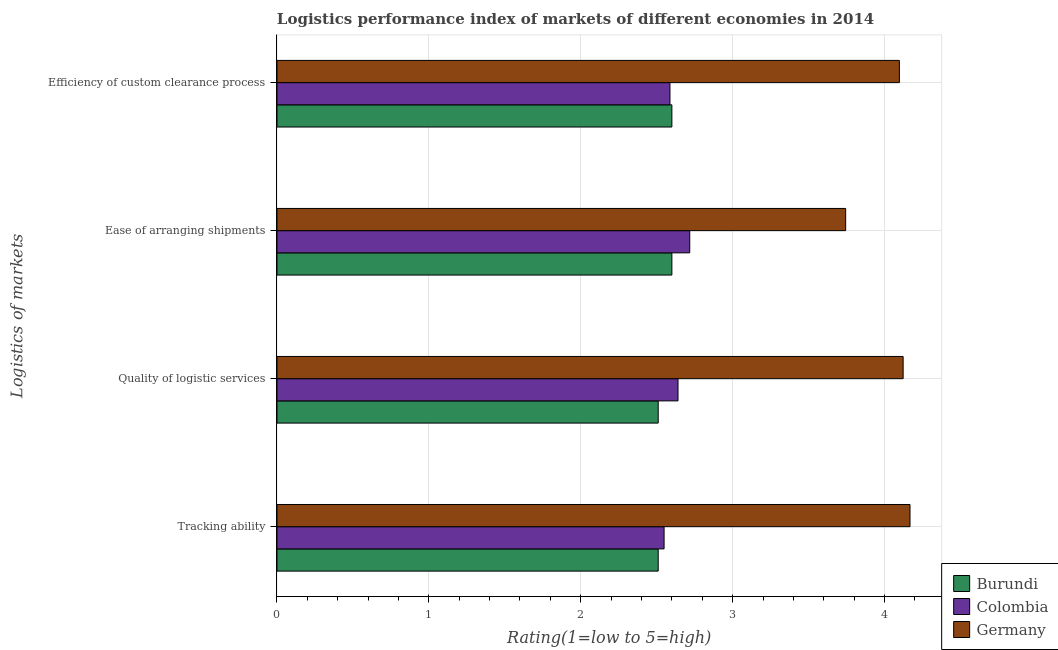How many different coloured bars are there?
Provide a short and direct response. 3. How many groups of bars are there?
Provide a short and direct response. 4. Are the number of bars per tick equal to the number of legend labels?
Your answer should be compact. Yes. What is the label of the 4th group of bars from the top?
Give a very brief answer. Tracking ability. What is the lpi rating of ease of arranging shipments in Germany?
Give a very brief answer. 3.74. Across all countries, what is the maximum lpi rating of quality of logistic services?
Offer a terse response. 4.12. Across all countries, what is the minimum lpi rating of ease of arranging shipments?
Offer a very short reply. 2.6. In which country was the lpi rating of quality of logistic services minimum?
Provide a short and direct response. Burundi. What is the total lpi rating of efficiency of custom clearance process in the graph?
Ensure brevity in your answer.  9.29. What is the difference between the lpi rating of ease of arranging shipments in Colombia and that in Germany?
Your answer should be very brief. -1.03. What is the difference between the lpi rating of quality of logistic services in Colombia and the lpi rating of efficiency of custom clearance process in Germany?
Offer a terse response. -1.46. What is the average lpi rating of efficiency of custom clearance process per country?
Provide a short and direct response. 3.1. What is the difference between the lpi rating of quality of logistic services and lpi rating of tracking ability in Colombia?
Your answer should be compact. 0.09. In how many countries, is the lpi rating of tracking ability greater than 0.6000000000000001 ?
Offer a very short reply. 3. What is the ratio of the lpi rating of tracking ability in Colombia to that in Germany?
Your answer should be compact. 0.61. Is the lpi rating of tracking ability in Germany less than that in Burundi?
Your response must be concise. No. Is the difference between the lpi rating of ease of arranging shipments in Burundi and Germany greater than the difference between the lpi rating of quality of logistic services in Burundi and Germany?
Provide a short and direct response. Yes. What is the difference between the highest and the second highest lpi rating of efficiency of custom clearance process?
Offer a very short reply. 1.5. What is the difference between the highest and the lowest lpi rating of tracking ability?
Ensure brevity in your answer.  1.66. In how many countries, is the lpi rating of ease of arranging shipments greater than the average lpi rating of ease of arranging shipments taken over all countries?
Keep it short and to the point. 1. Is it the case that in every country, the sum of the lpi rating of efficiency of custom clearance process and lpi rating of ease of arranging shipments is greater than the sum of lpi rating of quality of logistic services and lpi rating of tracking ability?
Provide a short and direct response. No. What does the 2nd bar from the top in Quality of logistic services represents?
Your response must be concise. Colombia. What does the 3rd bar from the bottom in Efficiency of custom clearance process represents?
Your answer should be compact. Germany. Is it the case that in every country, the sum of the lpi rating of tracking ability and lpi rating of quality of logistic services is greater than the lpi rating of ease of arranging shipments?
Provide a succinct answer. Yes. How many bars are there?
Provide a succinct answer. 12. How many countries are there in the graph?
Ensure brevity in your answer.  3. What is the difference between two consecutive major ticks on the X-axis?
Your response must be concise. 1. Are the values on the major ticks of X-axis written in scientific E-notation?
Offer a very short reply. No. How are the legend labels stacked?
Your answer should be very brief. Vertical. What is the title of the graph?
Keep it short and to the point. Logistics performance index of markets of different economies in 2014. Does "Syrian Arab Republic" appear as one of the legend labels in the graph?
Make the answer very short. No. What is the label or title of the X-axis?
Your answer should be compact. Rating(1=low to 5=high). What is the label or title of the Y-axis?
Offer a terse response. Logistics of markets. What is the Rating(1=low to 5=high) of Burundi in Tracking ability?
Give a very brief answer. 2.51. What is the Rating(1=low to 5=high) of Colombia in Tracking ability?
Provide a succinct answer. 2.55. What is the Rating(1=low to 5=high) in Germany in Tracking ability?
Your response must be concise. 4.17. What is the Rating(1=low to 5=high) in Burundi in Quality of logistic services?
Offer a terse response. 2.51. What is the Rating(1=low to 5=high) of Colombia in Quality of logistic services?
Ensure brevity in your answer.  2.64. What is the Rating(1=low to 5=high) in Germany in Quality of logistic services?
Your response must be concise. 4.12. What is the Rating(1=low to 5=high) in Burundi in Ease of arranging shipments?
Your response must be concise. 2.6. What is the Rating(1=low to 5=high) of Colombia in Ease of arranging shipments?
Your answer should be compact. 2.72. What is the Rating(1=low to 5=high) of Germany in Ease of arranging shipments?
Keep it short and to the point. 3.74. What is the Rating(1=low to 5=high) of Colombia in Efficiency of custom clearance process?
Your response must be concise. 2.59. What is the Rating(1=low to 5=high) of Germany in Efficiency of custom clearance process?
Your answer should be compact. 4.1. Across all Logistics of markets, what is the maximum Rating(1=low to 5=high) in Burundi?
Ensure brevity in your answer.  2.6. Across all Logistics of markets, what is the maximum Rating(1=low to 5=high) of Colombia?
Your answer should be compact. 2.72. Across all Logistics of markets, what is the maximum Rating(1=low to 5=high) in Germany?
Ensure brevity in your answer.  4.17. Across all Logistics of markets, what is the minimum Rating(1=low to 5=high) in Burundi?
Offer a terse response. 2.51. Across all Logistics of markets, what is the minimum Rating(1=low to 5=high) in Colombia?
Your answer should be compact. 2.55. Across all Logistics of markets, what is the minimum Rating(1=low to 5=high) of Germany?
Keep it short and to the point. 3.74. What is the total Rating(1=low to 5=high) in Burundi in the graph?
Provide a short and direct response. 10.22. What is the total Rating(1=low to 5=high) in Colombia in the graph?
Offer a very short reply. 10.49. What is the total Rating(1=low to 5=high) in Germany in the graph?
Keep it short and to the point. 16.13. What is the difference between the Rating(1=low to 5=high) in Colombia in Tracking ability and that in Quality of logistic services?
Keep it short and to the point. -0.09. What is the difference between the Rating(1=low to 5=high) of Germany in Tracking ability and that in Quality of logistic services?
Your response must be concise. 0.05. What is the difference between the Rating(1=low to 5=high) in Burundi in Tracking ability and that in Ease of arranging shipments?
Offer a terse response. -0.09. What is the difference between the Rating(1=low to 5=high) of Colombia in Tracking ability and that in Ease of arranging shipments?
Your response must be concise. -0.17. What is the difference between the Rating(1=low to 5=high) of Germany in Tracking ability and that in Ease of arranging shipments?
Your response must be concise. 0.42. What is the difference between the Rating(1=low to 5=high) in Burundi in Tracking ability and that in Efficiency of custom clearance process?
Keep it short and to the point. -0.09. What is the difference between the Rating(1=low to 5=high) of Colombia in Tracking ability and that in Efficiency of custom clearance process?
Give a very brief answer. -0.04. What is the difference between the Rating(1=low to 5=high) in Germany in Tracking ability and that in Efficiency of custom clearance process?
Provide a short and direct response. 0.07. What is the difference between the Rating(1=low to 5=high) in Burundi in Quality of logistic services and that in Ease of arranging shipments?
Your answer should be compact. -0.09. What is the difference between the Rating(1=low to 5=high) of Colombia in Quality of logistic services and that in Ease of arranging shipments?
Provide a short and direct response. -0.08. What is the difference between the Rating(1=low to 5=high) of Germany in Quality of logistic services and that in Ease of arranging shipments?
Provide a succinct answer. 0.38. What is the difference between the Rating(1=low to 5=high) of Burundi in Quality of logistic services and that in Efficiency of custom clearance process?
Ensure brevity in your answer.  -0.09. What is the difference between the Rating(1=low to 5=high) in Colombia in Quality of logistic services and that in Efficiency of custom clearance process?
Your answer should be compact. 0.05. What is the difference between the Rating(1=low to 5=high) of Germany in Quality of logistic services and that in Efficiency of custom clearance process?
Your response must be concise. 0.02. What is the difference between the Rating(1=low to 5=high) in Burundi in Ease of arranging shipments and that in Efficiency of custom clearance process?
Ensure brevity in your answer.  0. What is the difference between the Rating(1=low to 5=high) in Colombia in Ease of arranging shipments and that in Efficiency of custom clearance process?
Your answer should be very brief. 0.13. What is the difference between the Rating(1=low to 5=high) in Germany in Ease of arranging shipments and that in Efficiency of custom clearance process?
Make the answer very short. -0.35. What is the difference between the Rating(1=low to 5=high) in Burundi in Tracking ability and the Rating(1=low to 5=high) in Colombia in Quality of logistic services?
Your response must be concise. -0.13. What is the difference between the Rating(1=low to 5=high) of Burundi in Tracking ability and the Rating(1=low to 5=high) of Germany in Quality of logistic services?
Your answer should be very brief. -1.61. What is the difference between the Rating(1=low to 5=high) in Colombia in Tracking ability and the Rating(1=low to 5=high) in Germany in Quality of logistic services?
Your response must be concise. -1.57. What is the difference between the Rating(1=low to 5=high) of Burundi in Tracking ability and the Rating(1=low to 5=high) of Colombia in Ease of arranging shipments?
Provide a short and direct response. -0.21. What is the difference between the Rating(1=low to 5=high) in Burundi in Tracking ability and the Rating(1=low to 5=high) in Germany in Ease of arranging shipments?
Provide a short and direct response. -1.23. What is the difference between the Rating(1=low to 5=high) in Colombia in Tracking ability and the Rating(1=low to 5=high) in Germany in Ease of arranging shipments?
Your answer should be compact. -1.2. What is the difference between the Rating(1=low to 5=high) in Burundi in Tracking ability and the Rating(1=low to 5=high) in Colombia in Efficiency of custom clearance process?
Your response must be concise. -0.08. What is the difference between the Rating(1=low to 5=high) of Burundi in Tracking ability and the Rating(1=low to 5=high) of Germany in Efficiency of custom clearance process?
Ensure brevity in your answer.  -1.59. What is the difference between the Rating(1=low to 5=high) of Colombia in Tracking ability and the Rating(1=low to 5=high) of Germany in Efficiency of custom clearance process?
Provide a short and direct response. -1.55. What is the difference between the Rating(1=low to 5=high) of Burundi in Quality of logistic services and the Rating(1=low to 5=high) of Colombia in Ease of arranging shipments?
Your answer should be very brief. -0.21. What is the difference between the Rating(1=low to 5=high) in Burundi in Quality of logistic services and the Rating(1=low to 5=high) in Germany in Ease of arranging shipments?
Keep it short and to the point. -1.23. What is the difference between the Rating(1=low to 5=high) in Colombia in Quality of logistic services and the Rating(1=low to 5=high) in Germany in Ease of arranging shipments?
Give a very brief answer. -1.1. What is the difference between the Rating(1=low to 5=high) in Burundi in Quality of logistic services and the Rating(1=low to 5=high) in Colombia in Efficiency of custom clearance process?
Provide a succinct answer. -0.08. What is the difference between the Rating(1=low to 5=high) in Burundi in Quality of logistic services and the Rating(1=low to 5=high) in Germany in Efficiency of custom clearance process?
Provide a short and direct response. -1.59. What is the difference between the Rating(1=low to 5=high) in Colombia in Quality of logistic services and the Rating(1=low to 5=high) in Germany in Efficiency of custom clearance process?
Ensure brevity in your answer.  -1.46. What is the difference between the Rating(1=low to 5=high) of Burundi in Ease of arranging shipments and the Rating(1=low to 5=high) of Colombia in Efficiency of custom clearance process?
Ensure brevity in your answer.  0.01. What is the difference between the Rating(1=low to 5=high) in Burundi in Ease of arranging shipments and the Rating(1=low to 5=high) in Germany in Efficiency of custom clearance process?
Offer a terse response. -1.5. What is the difference between the Rating(1=low to 5=high) of Colombia in Ease of arranging shipments and the Rating(1=low to 5=high) of Germany in Efficiency of custom clearance process?
Keep it short and to the point. -1.38. What is the average Rating(1=low to 5=high) of Burundi per Logistics of markets?
Give a very brief answer. 2.56. What is the average Rating(1=low to 5=high) in Colombia per Logistics of markets?
Your response must be concise. 2.62. What is the average Rating(1=low to 5=high) in Germany per Logistics of markets?
Give a very brief answer. 4.03. What is the difference between the Rating(1=low to 5=high) in Burundi and Rating(1=low to 5=high) in Colombia in Tracking ability?
Your answer should be very brief. -0.04. What is the difference between the Rating(1=low to 5=high) in Burundi and Rating(1=low to 5=high) in Germany in Tracking ability?
Offer a terse response. -1.66. What is the difference between the Rating(1=low to 5=high) of Colombia and Rating(1=low to 5=high) of Germany in Tracking ability?
Your answer should be very brief. -1.62. What is the difference between the Rating(1=low to 5=high) of Burundi and Rating(1=low to 5=high) of Colombia in Quality of logistic services?
Keep it short and to the point. -0.13. What is the difference between the Rating(1=low to 5=high) in Burundi and Rating(1=low to 5=high) in Germany in Quality of logistic services?
Provide a succinct answer. -1.61. What is the difference between the Rating(1=low to 5=high) in Colombia and Rating(1=low to 5=high) in Germany in Quality of logistic services?
Ensure brevity in your answer.  -1.48. What is the difference between the Rating(1=low to 5=high) of Burundi and Rating(1=low to 5=high) of Colombia in Ease of arranging shipments?
Your answer should be very brief. -0.12. What is the difference between the Rating(1=low to 5=high) in Burundi and Rating(1=low to 5=high) in Germany in Ease of arranging shipments?
Your answer should be compact. -1.14. What is the difference between the Rating(1=low to 5=high) in Colombia and Rating(1=low to 5=high) in Germany in Ease of arranging shipments?
Keep it short and to the point. -1.03. What is the difference between the Rating(1=low to 5=high) of Burundi and Rating(1=low to 5=high) of Colombia in Efficiency of custom clearance process?
Make the answer very short. 0.01. What is the difference between the Rating(1=low to 5=high) in Burundi and Rating(1=low to 5=high) in Germany in Efficiency of custom clearance process?
Your answer should be very brief. -1.5. What is the difference between the Rating(1=low to 5=high) of Colombia and Rating(1=low to 5=high) of Germany in Efficiency of custom clearance process?
Ensure brevity in your answer.  -1.51. What is the ratio of the Rating(1=low to 5=high) of Colombia in Tracking ability to that in Quality of logistic services?
Keep it short and to the point. 0.97. What is the ratio of the Rating(1=low to 5=high) of Germany in Tracking ability to that in Quality of logistic services?
Keep it short and to the point. 1.01. What is the ratio of the Rating(1=low to 5=high) of Burundi in Tracking ability to that in Ease of arranging shipments?
Provide a short and direct response. 0.97. What is the ratio of the Rating(1=low to 5=high) in Colombia in Tracking ability to that in Ease of arranging shipments?
Your answer should be compact. 0.94. What is the ratio of the Rating(1=low to 5=high) in Germany in Tracking ability to that in Ease of arranging shipments?
Keep it short and to the point. 1.11. What is the ratio of the Rating(1=low to 5=high) of Burundi in Tracking ability to that in Efficiency of custom clearance process?
Provide a short and direct response. 0.97. What is the ratio of the Rating(1=low to 5=high) of Germany in Tracking ability to that in Efficiency of custom clearance process?
Provide a succinct answer. 1.02. What is the ratio of the Rating(1=low to 5=high) in Burundi in Quality of logistic services to that in Ease of arranging shipments?
Give a very brief answer. 0.97. What is the ratio of the Rating(1=low to 5=high) of Colombia in Quality of logistic services to that in Ease of arranging shipments?
Make the answer very short. 0.97. What is the ratio of the Rating(1=low to 5=high) in Germany in Quality of logistic services to that in Ease of arranging shipments?
Give a very brief answer. 1.1. What is the ratio of the Rating(1=low to 5=high) of Burundi in Quality of logistic services to that in Efficiency of custom clearance process?
Your response must be concise. 0.97. What is the ratio of the Rating(1=low to 5=high) of Colombia in Quality of logistic services to that in Efficiency of custom clearance process?
Provide a succinct answer. 1.02. What is the ratio of the Rating(1=low to 5=high) of Burundi in Ease of arranging shipments to that in Efficiency of custom clearance process?
Offer a terse response. 1. What is the ratio of the Rating(1=low to 5=high) of Colombia in Ease of arranging shipments to that in Efficiency of custom clearance process?
Your answer should be very brief. 1.05. What is the ratio of the Rating(1=low to 5=high) of Germany in Ease of arranging shipments to that in Efficiency of custom clearance process?
Give a very brief answer. 0.91. What is the difference between the highest and the second highest Rating(1=low to 5=high) in Colombia?
Offer a terse response. 0.08. What is the difference between the highest and the second highest Rating(1=low to 5=high) in Germany?
Your response must be concise. 0.05. What is the difference between the highest and the lowest Rating(1=low to 5=high) of Burundi?
Provide a short and direct response. 0.09. What is the difference between the highest and the lowest Rating(1=low to 5=high) of Colombia?
Offer a very short reply. 0.17. What is the difference between the highest and the lowest Rating(1=low to 5=high) in Germany?
Offer a very short reply. 0.42. 